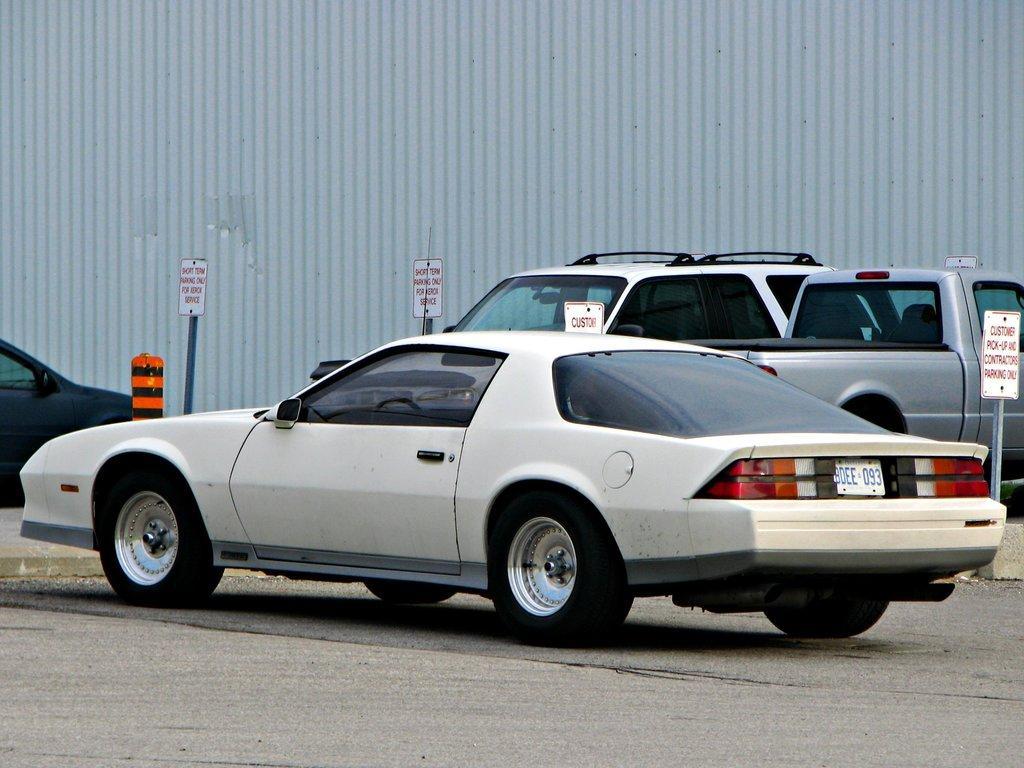In one or two sentences, can you explain what this image depicts? In this picture we can see vehicles on the road, boards on poles and object. In the background of the image we can see metal sheet. 